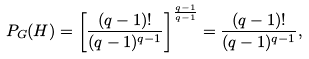<formula> <loc_0><loc_0><loc_500><loc_500>P _ { G } ( H ) = \left [ \frac { ( q - 1 ) ! } { ( q - 1 ) ^ { q - 1 } } \right ] ^ { \frac { q - 1 } { q - 1 } } = \frac { ( q - 1 ) ! } { ( q - 1 ) ^ { q - 1 } } ,</formula> 